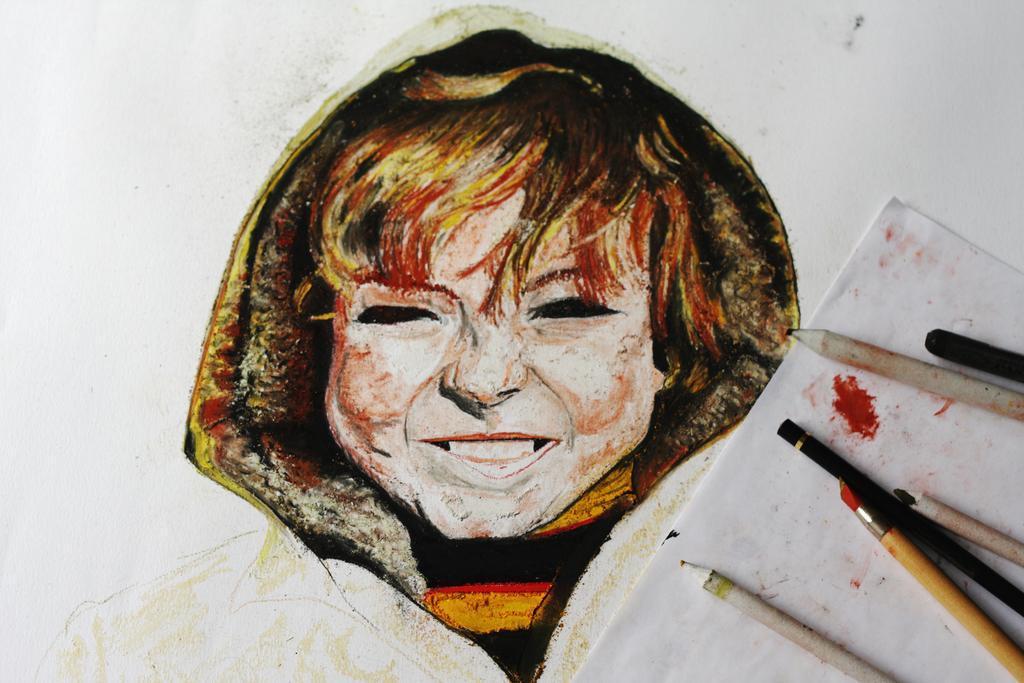In one or two sentences, can you explain what this image depicts? This image is a painting of a woman. Image also consists of sketch pencils placed on the paper. 